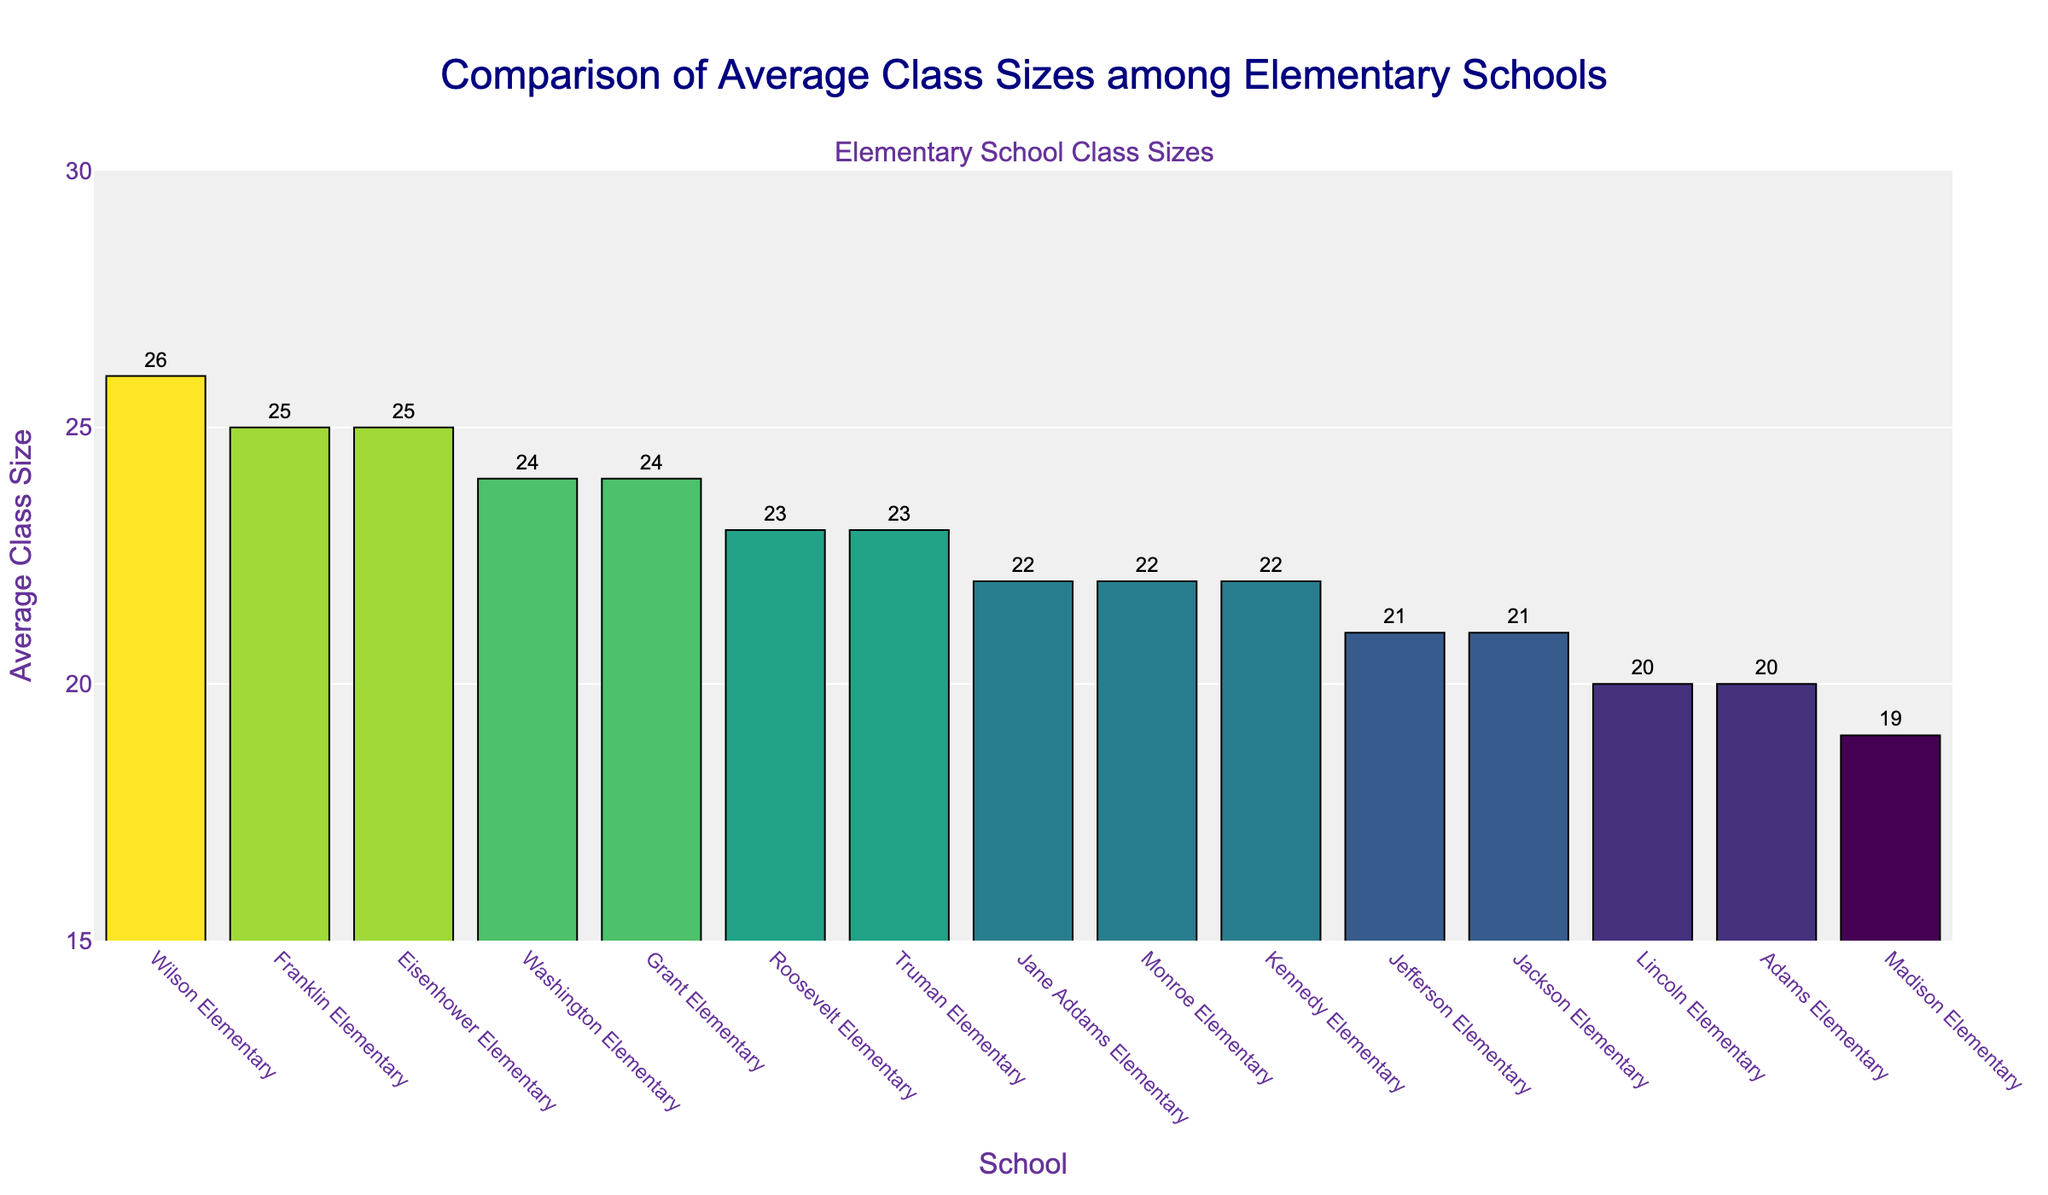What's the average class size at Jane Addams Elementary compared to Washington Elementary? Jane Addams Elementary has an average class size of 22, while Washington Elementary has an average class size of 24. The difference is 24 - 22 = 2.
Answer: Jane Addams: 22, Washington: 24 Which school has the largest average class size and what is that size? Wilson Elementary has the largest average class size. By inspecting the bar heights, Wilson Elementary has an average class size of 26.
Answer: Wilson Elementary: 26 How many schools have an average class size greater than 23? By examining the heights of the bars and the labels, the schools with an average class size greater than 23 are: Franklin Elementary (25), Eisenhower Elementary (25), Wilson Elementary (26), and Grant Elementary (24). This totals 4 schools.
Answer: 4 schools What is the difference in average class size between the largest and smallest schools? The school with the largest average class size is Wilson Elementary (26), and the school with the smallest average class size is Madison Elementary (19). The difference is 26 - 19 = 7.
Answer: 7 Which schools have the same average class size as Jane Addams Elementary, and what is that size? Jane Addams Elementary has an average class size of 22. By comparing the heights and labels, Monroe Elementary and Kennedy Elementary also have an average class size of 22.
Answer: Jane Addams, Monroe, Kennedy: 22 What's the total average class size across all schools? By summing the average class sizes of all listed schools in the figure: 22 + 24 + 20 + 23 + 21 + 25 + 19 + 26 + 22 + 20 + 24 + 21 + 23 + 25 + 22 = 317.
Answer: 317 Which school has a smaller average class size: Jefferson Elementary or Jackson Elementary, and what are their sizes? Jefferson Elementary has an average class size of 21, and Jackson Elementary also has an average class size of 21. Both schools have the same average class size.
Answer: Both: 21 Are there more schools with average class sizes above or below 22? Schools with average class size above 22 are: Washington Elementary (24), Roosevelt Elementary (23), Franklin Elementary (25), Wilson Elementary (26), Grant Elementary (24), Eisenhower Elementary (25), and Truman Elementary (23) - total 7 schools. Schools with average class size below 22 are: Lincoln Elementary (20), Madison Elementary (19), Adams Elementary (20), and Jefferson Elementary (21), Jackson Elementary (21) - total 5 schools. Therefore, there are more schools with average class sizes above 22.
Answer: Above: 7, Below: 5 What's the median average class size of all schools? To find the median, sort the average class sizes: 19, 20, 20, 21, 21, 22, 22, 22, 23, 23, 24, 24, 25, 25, 26. The median is the middle value, which is 22.
Answer: 22 